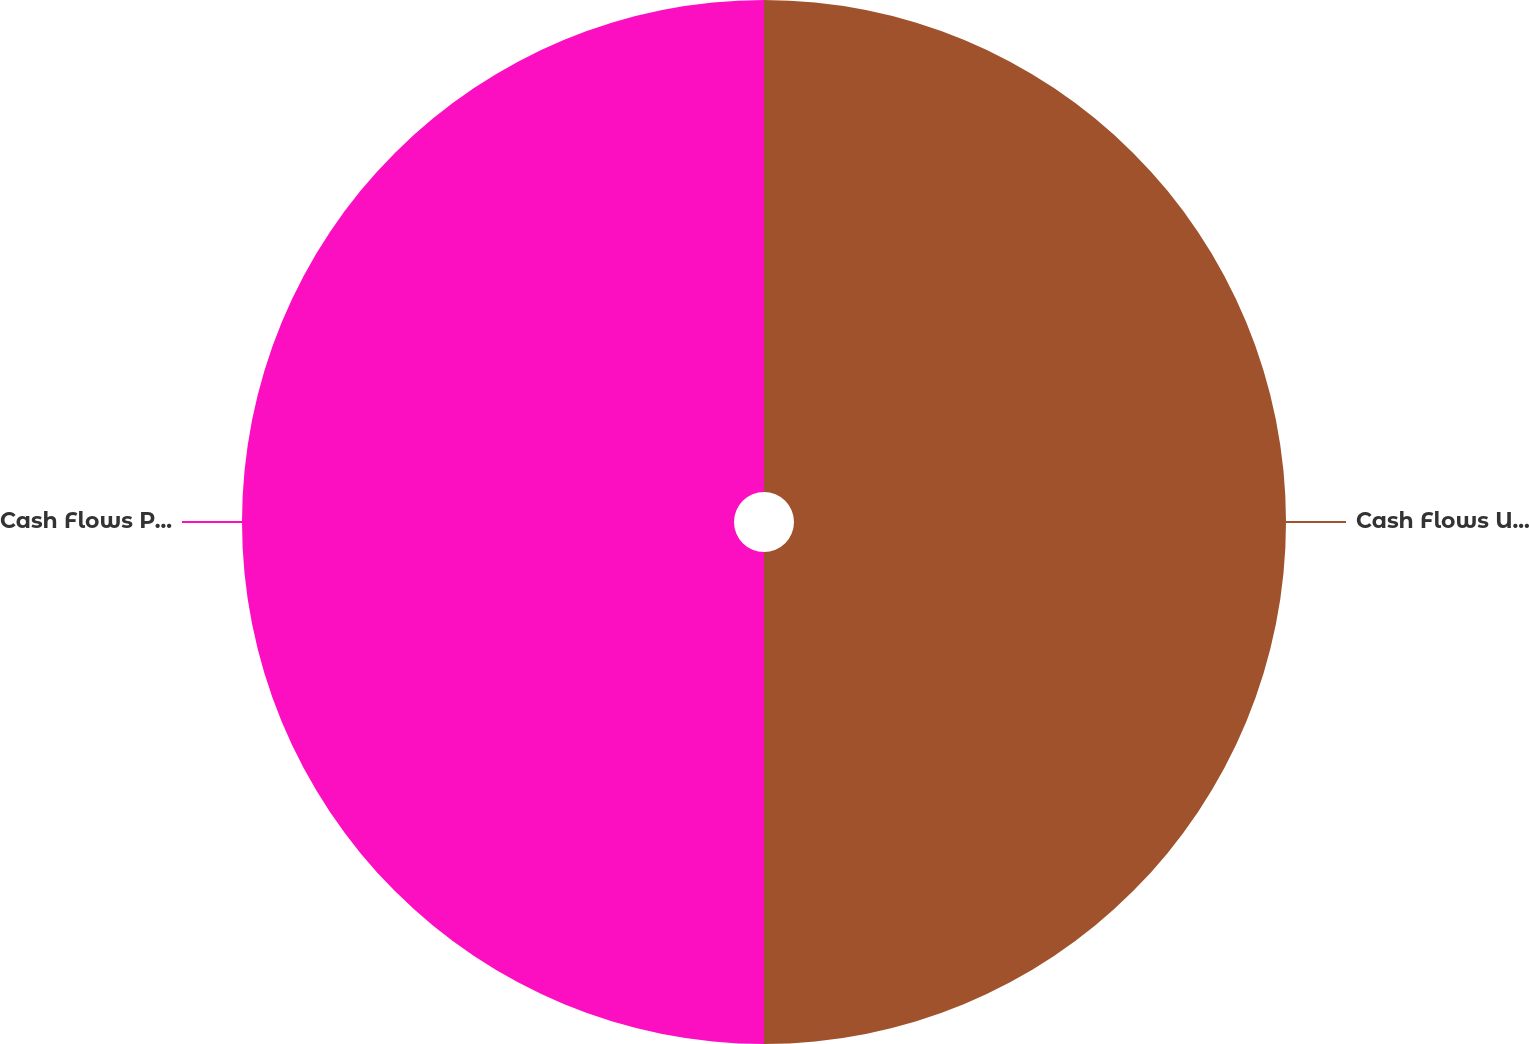Convert chart. <chart><loc_0><loc_0><loc_500><loc_500><pie_chart><fcel>Cash Flows Used in Investing<fcel>Cash Flows Provided by (Used<nl><fcel>50.0%<fcel>50.0%<nl></chart> 